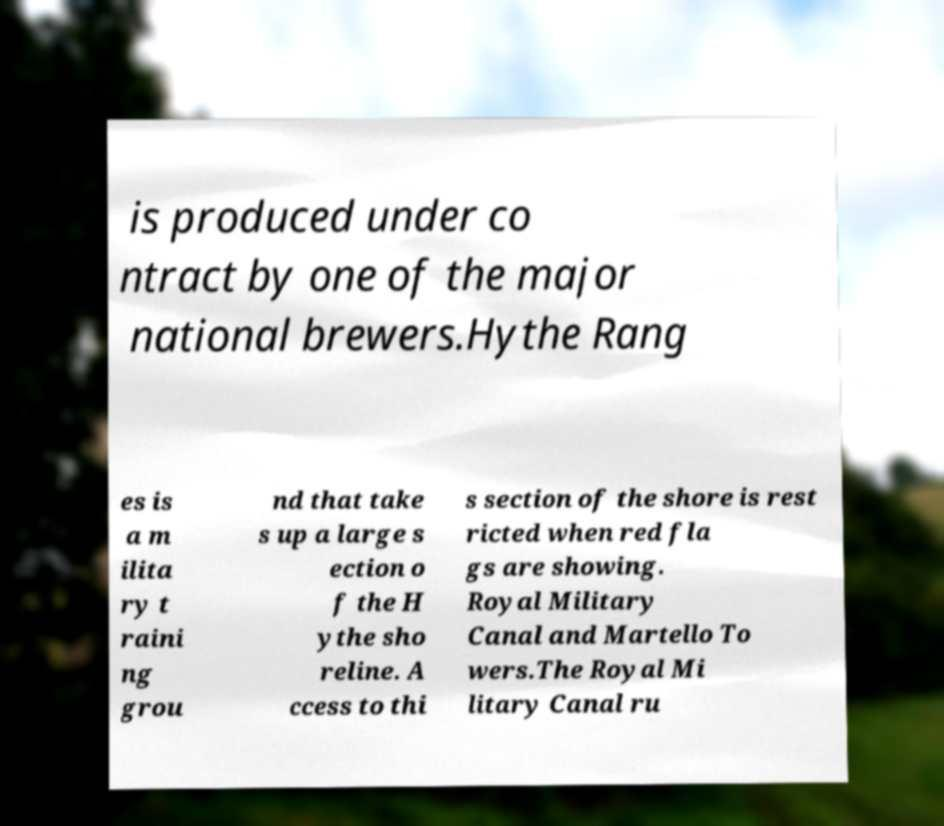Could you extract and type out the text from this image? is produced under co ntract by one of the major national brewers.Hythe Rang es is a m ilita ry t raini ng grou nd that take s up a large s ection o f the H ythe sho reline. A ccess to thi s section of the shore is rest ricted when red fla gs are showing. Royal Military Canal and Martello To wers.The Royal Mi litary Canal ru 